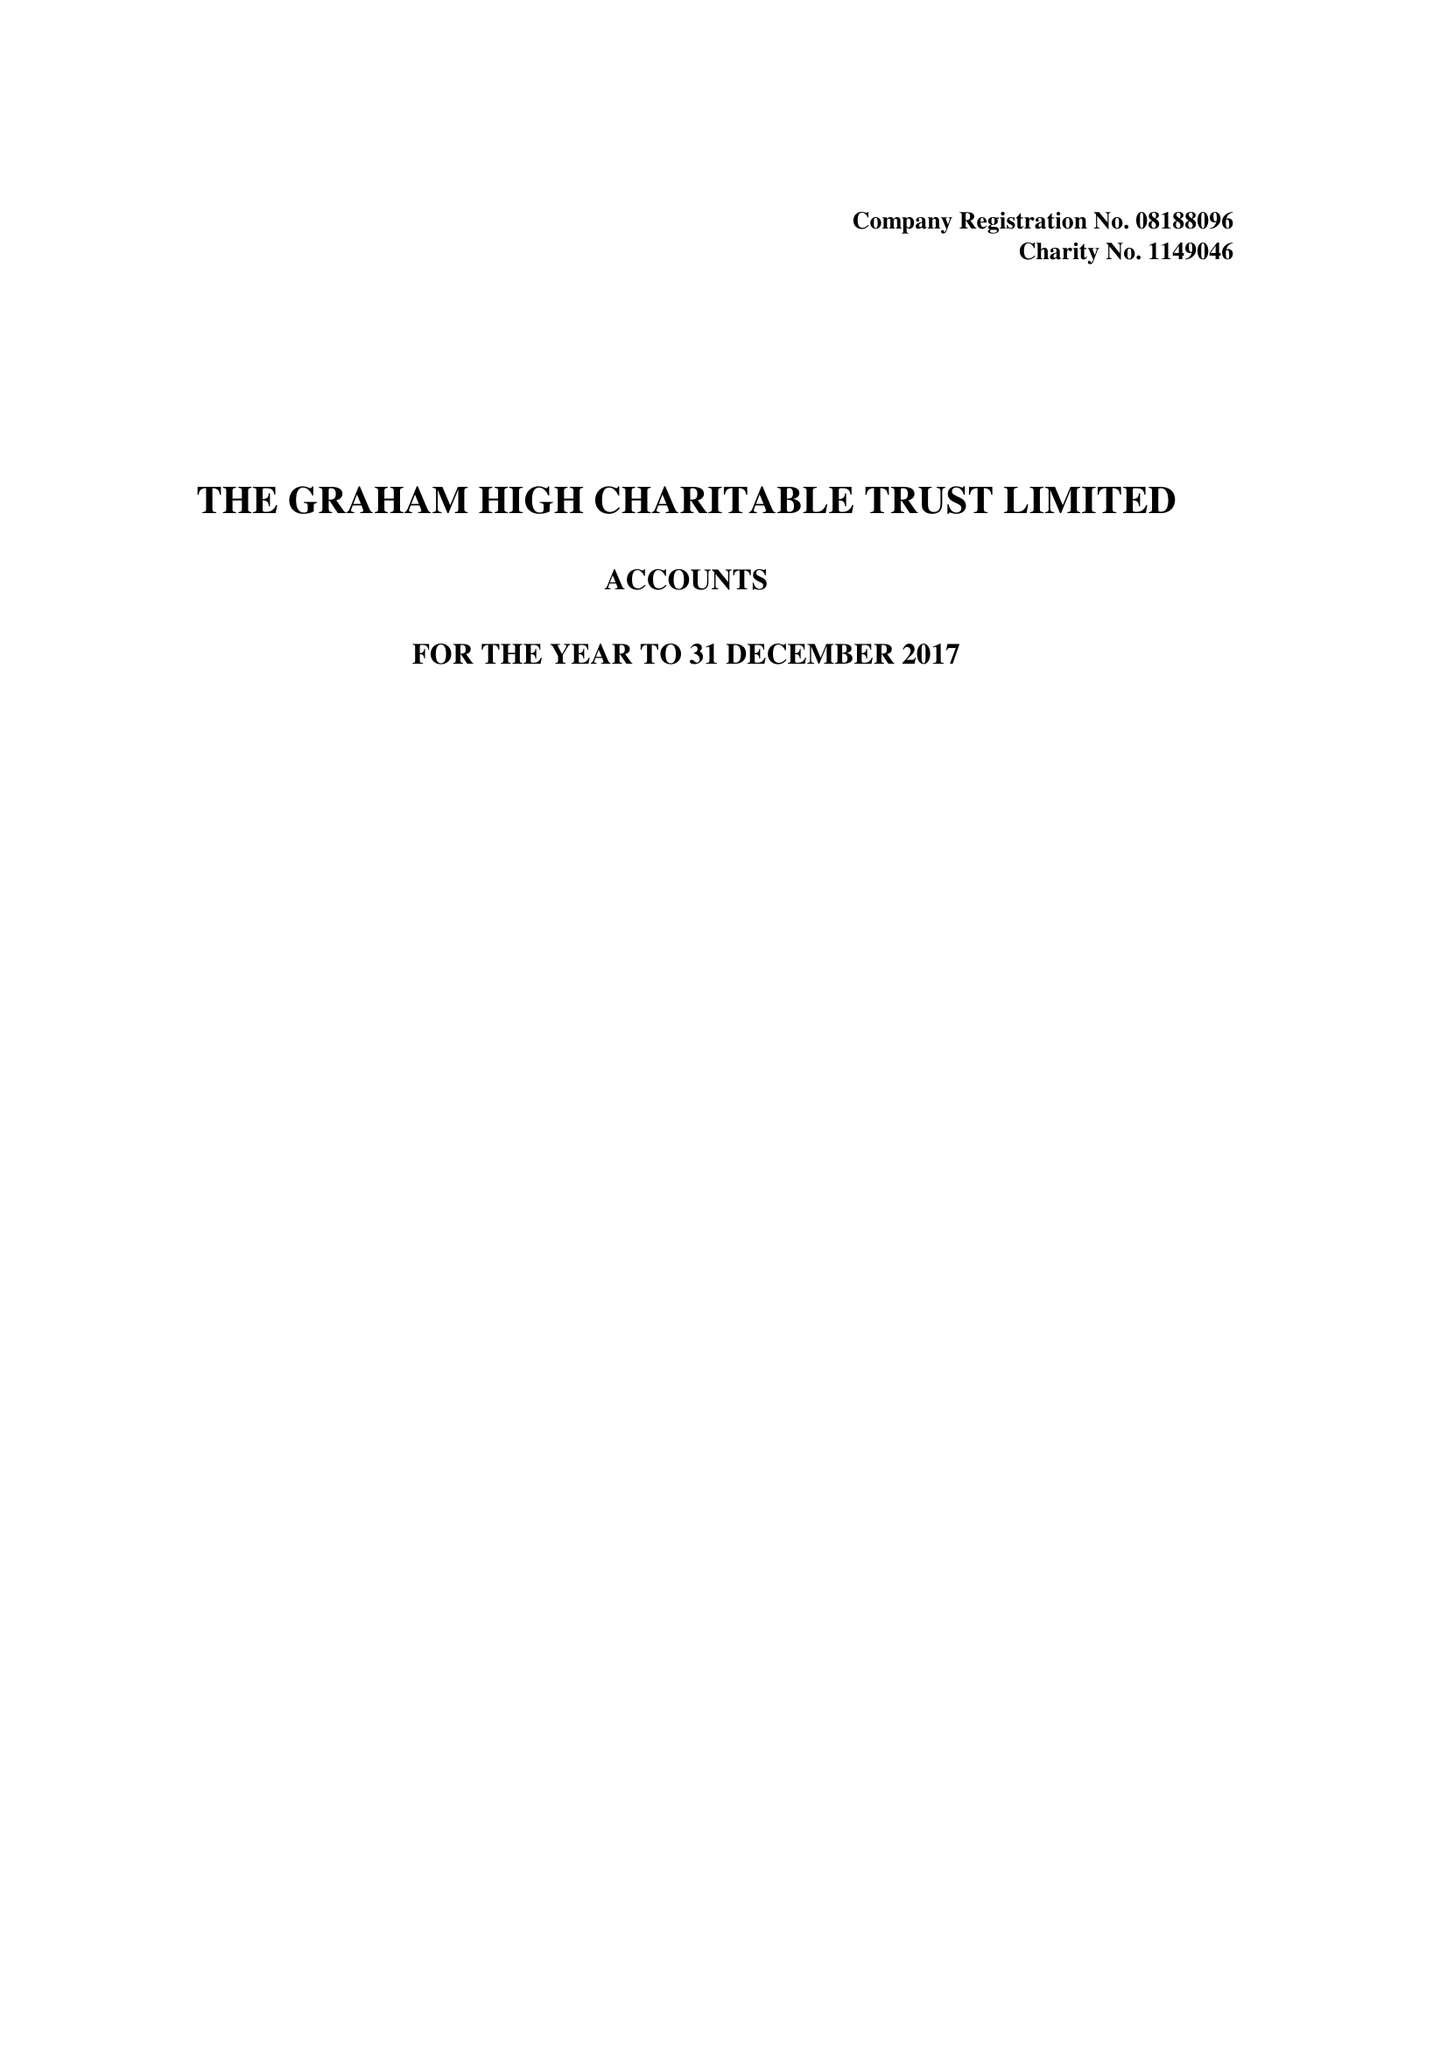What is the value for the income_annually_in_british_pounds?
Answer the question using a single word or phrase. 29034.00 